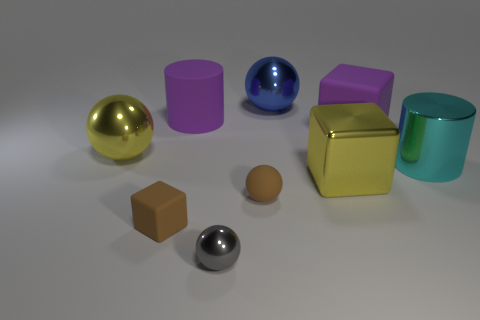Subtract all yellow balls. How many balls are left? 3 Subtract all large cubes. How many cubes are left? 1 Subtract 0 cyan cubes. How many objects are left? 9 Subtract all cylinders. How many objects are left? 7 Subtract 1 cubes. How many cubes are left? 2 Subtract all purple balls. Subtract all green cubes. How many balls are left? 4 Subtract all brown cubes. How many cyan cylinders are left? 1 Subtract all large purple rubber spheres. Subtract all brown blocks. How many objects are left? 8 Add 7 yellow balls. How many yellow balls are left? 8 Add 5 large rubber cylinders. How many large rubber cylinders exist? 6 